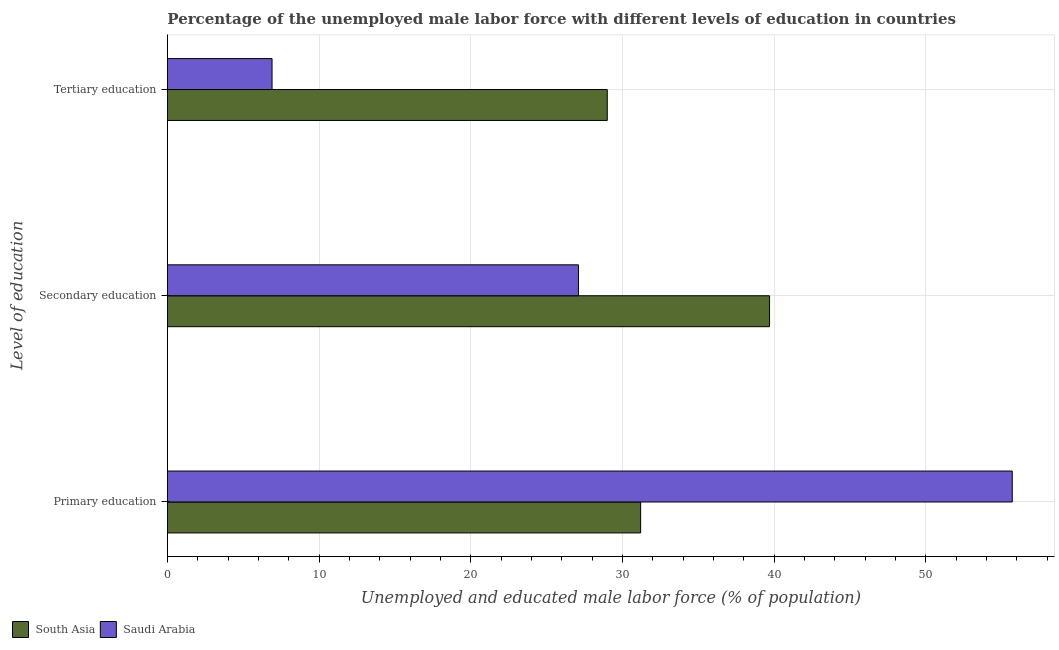How many groups of bars are there?
Provide a short and direct response. 3. Are the number of bars per tick equal to the number of legend labels?
Your answer should be very brief. Yes. How many bars are there on the 1st tick from the top?
Your answer should be very brief. 2. What is the percentage of male labor force who received tertiary education in Saudi Arabia?
Provide a short and direct response. 6.9. Across all countries, what is the maximum percentage of male labor force who received secondary education?
Provide a succinct answer. 39.7. Across all countries, what is the minimum percentage of male labor force who received secondary education?
Make the answer very short. 27.1. In which country was the percentage of male labor force who received secondary education maximum?
Your answer should be very brief. South Asia. In which country was the percentage of male labor force who received primary education minimum?
Your response must be concise. South Asia. What is the total percentage of male labor force who received primary education in the graph?
Offer a very short reply. 86.9. What is the difference between the percentage of male labor force who received primary education in Saudi Arabia and that in South Asia?
Your answer should be compact. 24.5. What is the difference between the percentage of male labor force who received tertiary education in South Asia and the percentage of male labor force who received primary education in Saudi Arabia?
Your answer should be compact. -26.7. What is the average percentage of male labor force who received primary education per country?
Keep it short and to the point. 43.45. What is the difference between the percentage of male labor force who received tertiary education and percentage of male labor force who received primary education in Saudi Arabia?
Offer a very short reply. -48.8. What is the ratio of the percentage of male labor force who received primary education in South Asia to that in Saudi Arabia?
Make the answer very short. 0.56. What is the difference between the highest and the second highest percentage of male labor force who received tertiary education?
Give a very brief answer. 22.1. What is the difference between the highest and the lowest percentage of male labor force who received primary education?
Offer a very short reply. 24.5. In how many countries, is the percentage of male labor force who received secondary education greater than the average percentage of male labor force who received secondary education taken over all countries?
Offer a very short reply. 1. What does the 1st bar from the top in Tertiary education represents?
Your response must be concise. Saudi Arabia. What does the 2nd bar from the bottom in Secondary education represents?
Offer a very short reply. Saudi Arabia. Is it the case that in every country, the sum of the percentage of male labor force who received primary education and percentage of male labor force who received secondary education is greater than the percentage of male labor force who received tertiary education?
Keep it short and to the point. Yes. Are the values on the major ticks of X-axis written in scientific E-notation?
Ensure brevity in your answer.  No. Does the graph contain any zero values?
Provide a succinct answer. No. Does the graph contain grids?
Make the answer very short. Yes. How many legend labels are there?
Your response must be concise. 2. How are the legend labels stacked?
Offer a terse response. Horizontal. What is the title of the graph?
Give a very brief answer. Percentage of the unemployed male labor force with different levels of education in countries. What is the label or title of the X-axis?
Your response must be concise. Unemployed and educated male labor force (% of population). What is the label or title of the Y-axis?
Offer a terse response. Level of education. What is the Unemployed and educated male labor force (% of population) of South Asia in Primary education?
Ensure brevity in your answer.  31.2. What is the Unemployed and educated male labor force (% of population) in Saudi Arabia in Primary education?
Ensure brevity in your answer.  55.7. What is the Unemployed and educated male labor force (% of population) of South Asia in Secondary education?
Ensure brevity in your answer.  39.7. What is the Unemployed and educated male labor force (% of population) of Saudi Arabia in Secondary education?
Your answer should be very brief. 27.1. What is the Unemployed and educated male labor force (% of population) in South Asia in Tertiary education?
Provide a succinct answer. 29. What is the Unemployed and educated male labor force (% of population) in Saudi Arabia in Tertiary education?
Your answer should be compact. 6.9. Across all Level of education, what is the maximum Unemployed and educated male labor force (% of population) of South Asia?
Provide a succinct answer. 39.7. Across all Level of education, what is the maximum Unemployed and educated male labor force (% of population) in Saudi Arabia?
Your answer should be very brief. 55.7. Across all Level of education, what is the minimum Unemployed and educated male labor force (% of population) in South Asia?
Give a very brief answer. 29. Across all Level of education, what is the minimum Unemployed and educated male labor force (% of population) of Saudi Arabia?
Give a very brief answer. 6.9. What is the total Unemployed and educated male labor force (% of population) in South Asia in the graph?
Offer a terse response. 99.9. What is the total Unemployed and educated male labor force (% of population) of Saudi Arabia in the graph?
Keep it short and to the point. 89.7. What is the difference between the Unemployed and educated male labor force (% of population) of Saudi Arabia in Primary education and that in Secondary education?
Make the answer very short. 28.6. What is the difference between the Unemployed and educated male labor force (% of population) of Saudi Arabia in Primary education and that in Tertiary education?
Your answer should be very brief. 48.8. What is the difference between the Unemployed and educated male labor force (% of population) in South Asia in Secondary education and that in Tertiary education?
Provide a succinct answer. 10.7. What is the difference between the Unemployed and educated male labor force (% of population) of Saudi Arabia in Secondary education and that in Tertiary education?
Provide a succinct answer. 20.2. What is the difference between the Unemployed and educated male labor force (% of population) of South Asia in Primary education and the Unemployed and educated male labor force (% of population) of Saudi Arabia in Secondary education?
Ensure brevity in your answer.  4.1. What is the difference between the Unemployed and educated male labor force (% of population) in South Asia in Primary education and the Unemployed and educated male labor force (% of population) in Saudi Arabia in Tertiary education?
Your answer should be compact. 24.3. What is the difference between the Unemployed and educated male labor force (% of population) of South Asia in Secondary education and the Unemployed and educated male labor force (% of population) of Saudi Arabia in Tertiary education?
Offer a very short reply. 32.8. What is the average Unemployed and educated male labor force (% of population) of South Asia per Level of education?
Provide a short and direct response. 33.3. What is the average Unemployed and educated male labor force (% of population) in Saudi Arabia per Level of education?
Make the answer very short. 29.9. What is the difference between the Unemployed and educated male labor force (% of population) in South Asia and Unemployed and educated male labor force (% of population) in Saudi Arabia in Primary education?
Keep it short and to the point. -24.5. What is the difference between the Unemployed and educated male labor force (% of population) in South Asia and Unemployed and educated male labor force (% of population) in Saudi Arabia in Tertiary education?
Your answer should be compact. 22.1. What is the ratio of the Unemployed and educated male labor force (% of population) in South Asia in Primary education to that in Secondary education?
Provide a short and direct response. 0.79. What is the ratio of the Unemployed and educated male labor force (% of population) in Saudi Arabia in Primary education to that in Secondary education?
Offer a very short reply. 2.06. What is the ratio of the Unemployed and educated male labor force (% of population) in South Asia in Primary education to that in Tertiary education?
Make the answer very short. 1.08. What is the ratio of the Unemployed and educated male labor force (% of population) of Saudi Arabia in Primary education to that in Tertiary education?
Your response must be concise. 8.07. What is the ratio of the Unemployed and educated male labor force (% of population) of South Asia in Secondary education to that in Tertiary education?
Your response must be concise. 1.37. What is the ratio of the Unemployed and educated male labor force (% of population) of Saudi Arabia in Secondary education to that in Tertiary education?
Offer a terse response. 3.93. What is the difference between the highest and the second highest Unemployed and educated male labor force (% of population) in South Asia?
Provide a short and direct response. 8.5. What is the difference between the highest and the second highest Unemployed and educated male labor force (% of population) of Saudi Arabia?
Your answer should be very brief. 28.6. What is the difference between the highest and the lowest Unemployed and educated male labor force (% of population) in Saudi Arabia?
Ensure brevity in your answer.  48.8. 